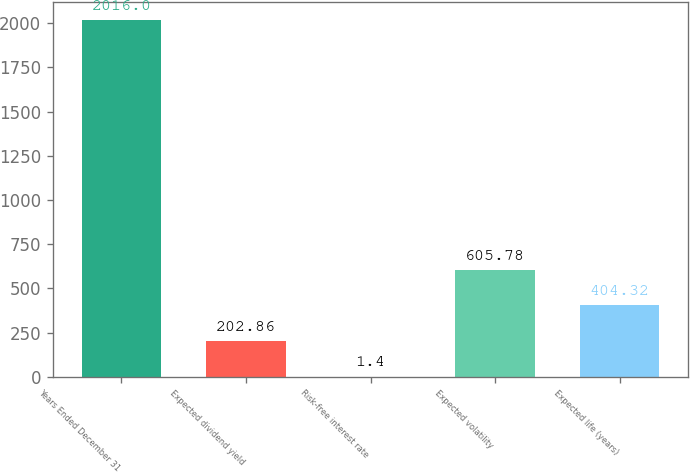Convert chart to OTSL. <chart><loc_0><loc_0><loc_500><loc_500><bar_chart><fcel>Years Ended December 31<fcel>Expected dividend yield<fcel>Risk-free interest rate<fcel>Expected volatility<fcel>Expected life (years)<nl><fcel>2016<fcel>202.86<fcel>1.4<fcel>605.78<fcel>404.32<nl></chart> 